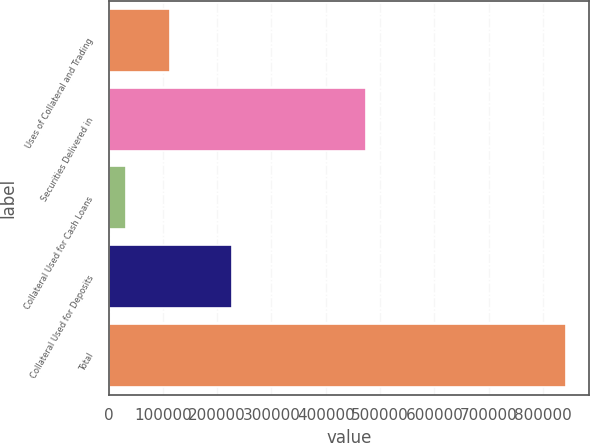Convert chart. <chart><loc_0><loc_0><loc_500><loc_500><bar_chart><fcel>Uses of Collateral and Trading<fcel>Securities Delivered in<fcel>Collateral Used for Cash Loans<fcel>Collateral Used for Deposits<fcel>Total<nl><fcel>113435<fcel>474890<fcel>32434<fcel>227035<fcel>842444<nl></chart> 